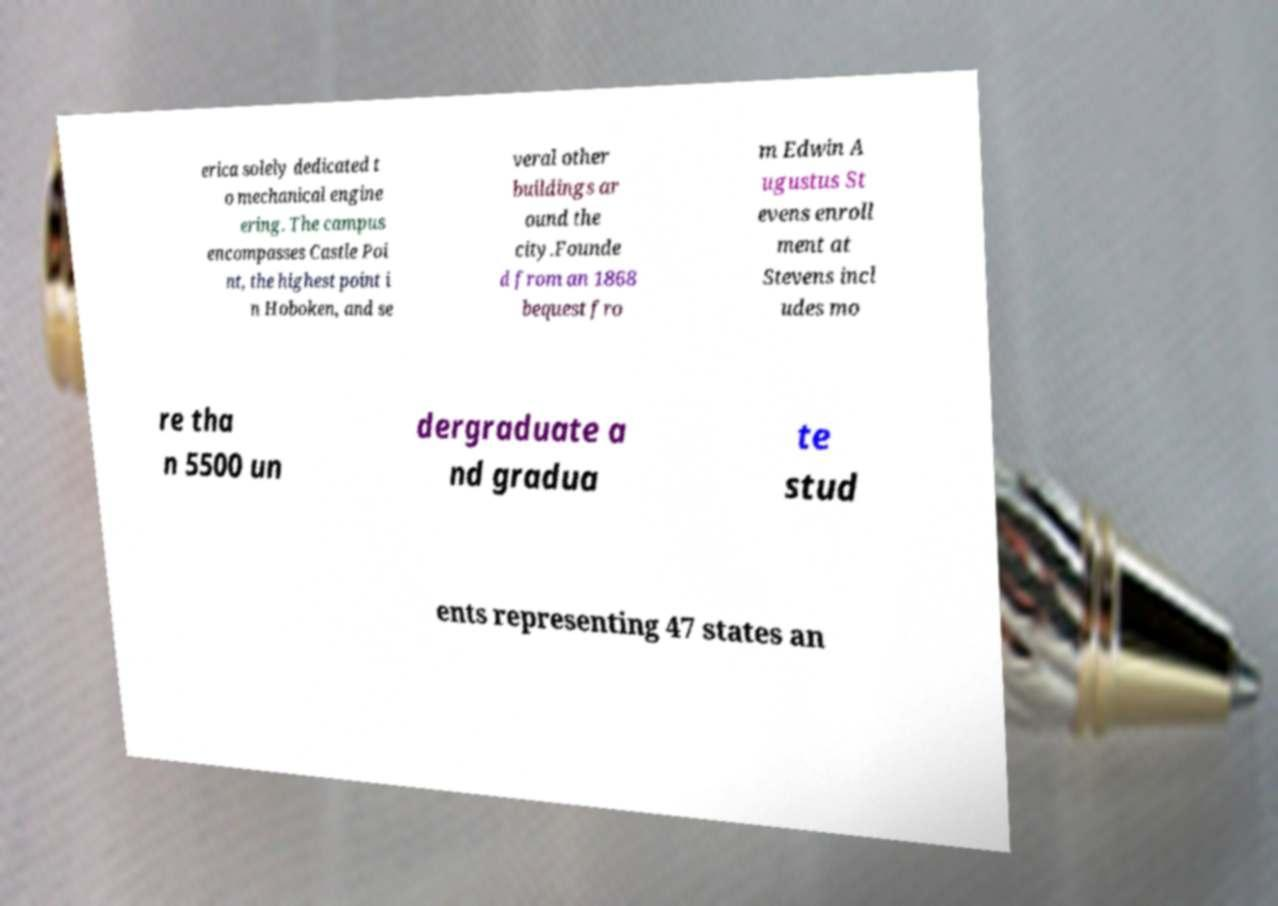Please read and relay the text visible in this image. What does it say? erica solely dedicated t o mechanical engine ering. The campus encompasses Castle Poi nt, the highest point i n Hoboken, and se veral other buildings ar ound the city.Founde d from an 1868 bequest fro m Edwin A ugustus St evens enroll ment at Stevens incl udes mo re tha n 5500 un dergraduate a nd gradua te stud ents representing 47 states an 